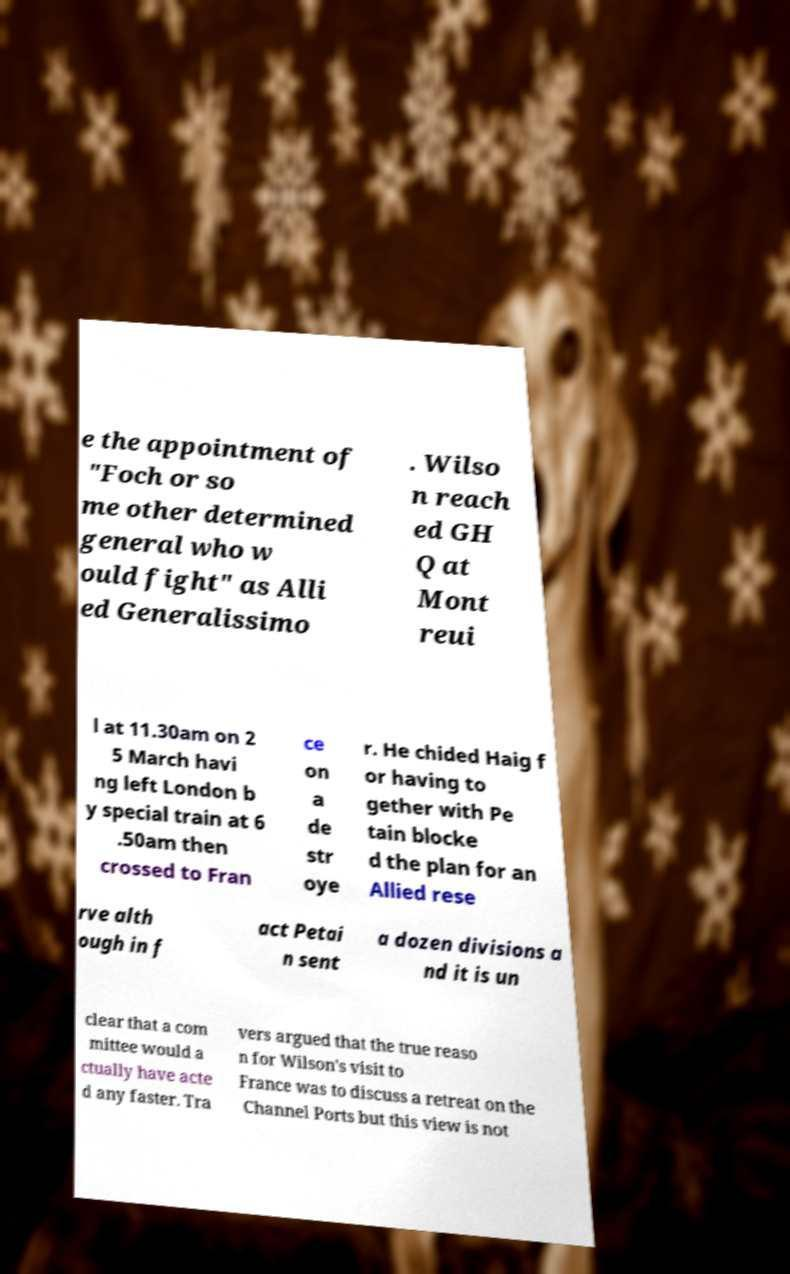What messages or text are displayed in this image? I need them in a readable, typed format. e the appointment of "Foch or so me other determined general who w ould fight" as Alli ed Generalissimo . Wilso n reach ed GH Q at Mont reui l at 11.30am on 2 5 March havi ng left London b y special train at 6 .50am then crossed to Fran ce on a de str oye r. He chided Haig f or having to gether with Pe tain blocke d the plan for an Allied rese rve alth ough in f act Petai n sent a dozen divisions a nd it is un clear that a com mittee would a ctually have acte d any faster. Tra vers argued that the true reaso n for Wilson's visit to France was to discuss a retreat on the Channel Ports but this view is not 